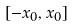<formula> <loc_0><loc_0><loc_500><loc_500>[ - x _ { 0 } , x _ { 0 } ]</formula> 